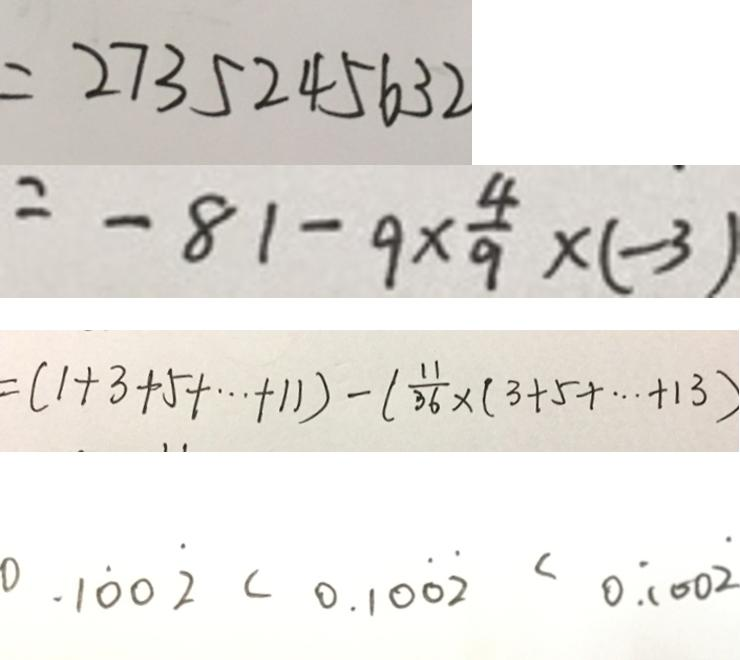Convert formula to latex. <formula><loc_0><loc_0><loc_500><loc_500>= 2 7 3 5 2 4 5 6 3 2 
 = - 8 1 - 9 \times \frac { 4 } { 9 } \times ( - 3 ) 
 = ( 1 + 3 + 5 + \cdots + 1 1 ) - ( \frac { 1 1 } { 3 6 } \times ( 3 + 5 + \cdots + 1 3 ) 
 0 . 1 \dot { 0 } 0 \dot { 2 } < 0 . 1 0 \dot { 0 } \dot { 2 } < 0 . \dot { 1 } 0 0 \dot { 2 }</formula> 